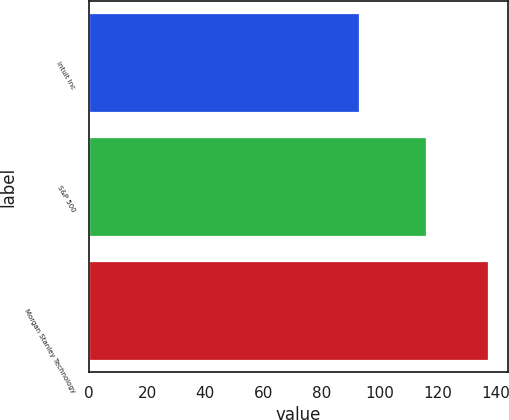Convert chart to OTSL. <chart><loc_0><loc_0><loc_500><loc_500><bar_chart><fcel>Intuit Inc<fcel>S&P 500<fcel>Morgan Stanley Technology<nl><fcel>92.78<fcel>116.13<fcel>137.24<nl></chart> 